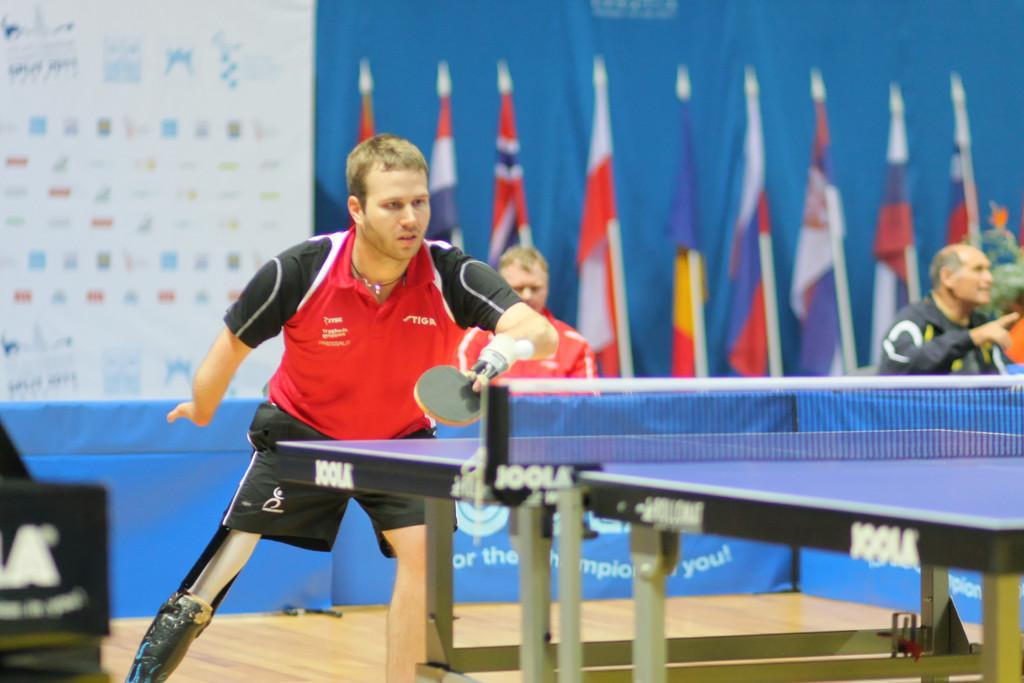<image>
Create a compact narrative representing the image presented. Man in red Tiga labelled shirt is playing ping pong on a table made by Joola. 